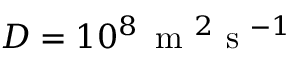<formula> <loc_0><loc_0><loc_500><loc_500>D = 1 0 ^ { 8 } \, m ^ { 2 } s ^ { - 1 }</formula> 